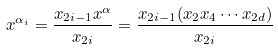Convert formula to latex. <formula><loc_0><loc_0><loc_500><loc_500>x ^ { \alpha _ { i } } = \frac { x _ { 2 i - 1 } x ^ { \alpha } } { x _ { 2 i } } = \frac { x _ { 2 i - 1 } ( x _ { 2 } x _ { 4 } \cdots x _ { 2 d } ) } { x _ { 2 i } }</formula> 